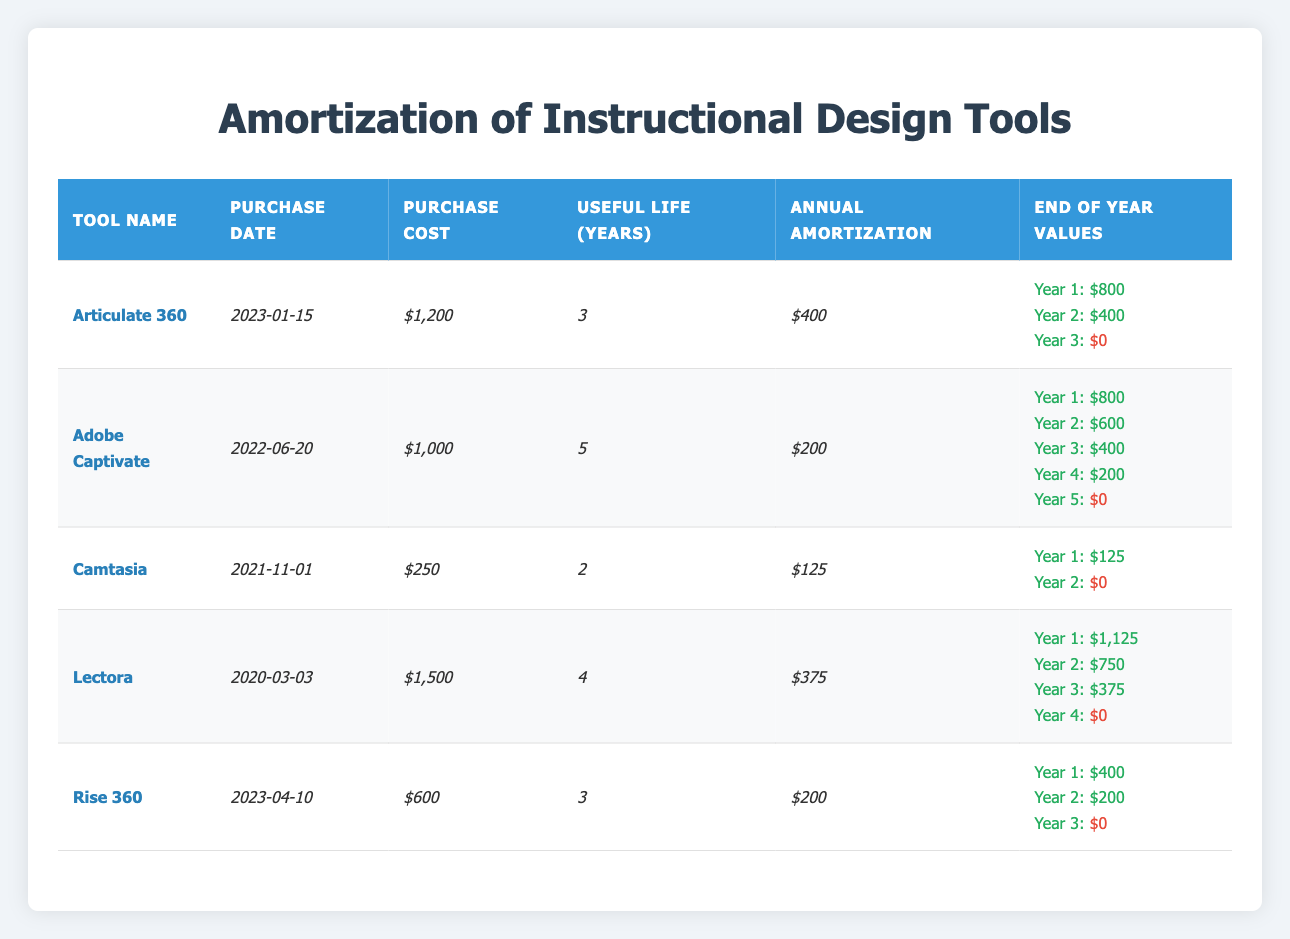What is the purchase cost of Articulate 360? The table lists Articulate 360 under the "Tool Name" column, and the corresponding purchase cost is $1,200 indicated in the "Purchase Cost" column.
Answer: $1,200 What is the useful life of Adobe Captivate? By checking the "Useful Life (Years)" column corresponding to Adobe Captivate in the table, it is noted that its useful life is 5 years.
Answer: 5 years How much is the annual amortization for Lectora? Looking at the "Annual Amortization" column for Lectora, the value listed is $375, which is the annual amortization amount for this specific tool.
Answer: $375 Is the end-of-year value for Camtasia zero at the end of its useful life? The end-of-year values for Camtasia show that the value is indeed $0 at the end of year 2, confirming that the end-of-life value is zero as it fully depreciates.
Answer: Yes What is the total purchase cost of all the tools listed? Calculating the total involves summing the purchase costs of all listed tools: $1,200 (Articulate 360) + $1,000 (Adobe Captivate) + $250 (Camtasia) + $1,500 (Lectora) + $600 (Rise 360) = $4,550.
Answer: $4,550 How long will it take for the value of Rise 360 to reach zero? The end-of-year values for Rise 360 indicate it will take 3 years for its value to decline to $0, as shown in the "End of Year Values" section.
Answer: 3 years What is the average annual amortization of all the tools? The annual amortization amounts are: $400 (Articulate 360), $200 (Adobe Captivate), $125 (Camtasia), $375 (Lectora), and $200 (Rise 360). The total is $400 + $200 + $125 + $375 + $200 = $1,300. There are 5 tools, so the average is $1,300 / 5 = $260.
Answer: $260 How much value does Adobe Captivate have left at the end of Year 3? Referring to the end-of-year values for Adobe Captivate, Year 3 shows a remaining value of $400, indicating that it has depreciated to this amount by the end of the third year.
Answer: $400 Does any tool have an annual amortization greater than $400? By examining the annual amortization values in the table, we see that the maximum is $400 for Articulate 360, and no other tools exceed this amount, confirming that no tool has a greater annual amortization.
Answer: No 